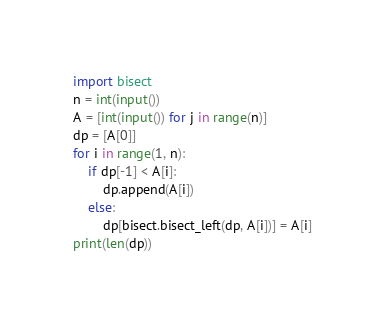<code> <loc_0><loc_0><loc_500><loc_500><_Python_>import bisect
n = int(input())
A = [int(input()) for j in range(n)]
dp = [A[0]]
for i in range(1, n):
    if dp[-1] < A[i]:
        dp.append(A[i])
    else:
        dp[bisect.bisect_left(dp, A[i])] = A[i]
print(len(dp))</code> 